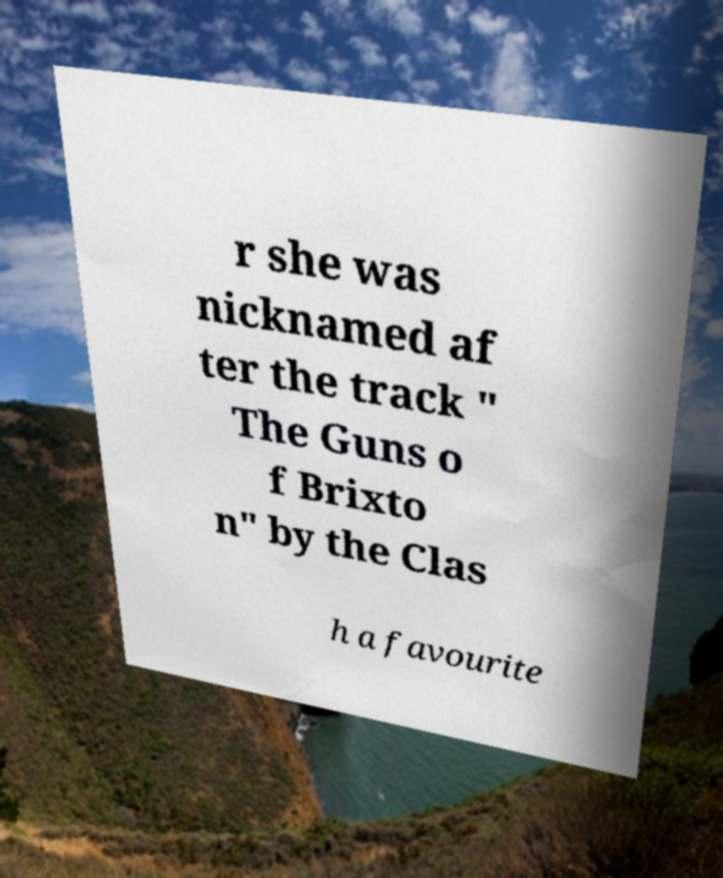Please identify and transcribe the text found in this image. r she was nicknamed af ter the track " The Guns o f Brixto n" by the Clas h a favourite 